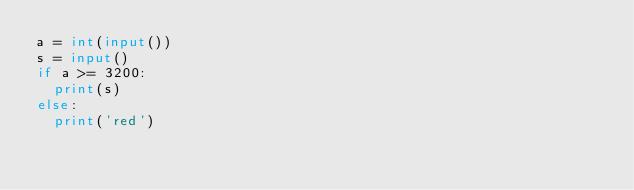<code> <loc_0><loc_0><loc_500><loc_500><_Python_>a = int(input())
s = input()
if a >= 3200:
  print(s)
else:
  print('red')</code> 